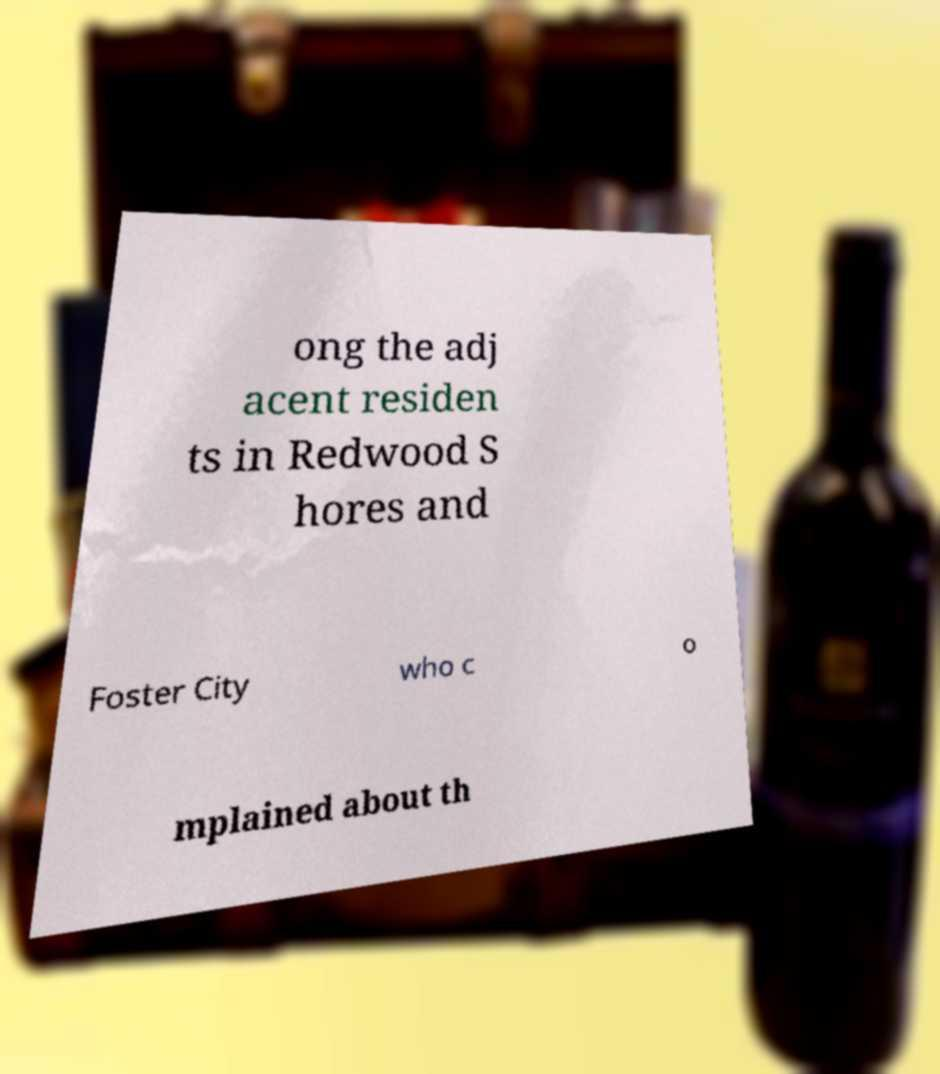I need the written content from this picture converted into text. Can you do that? ong the adj acent residen ts in Redwood S hores and Foster City who c o mplained about th 